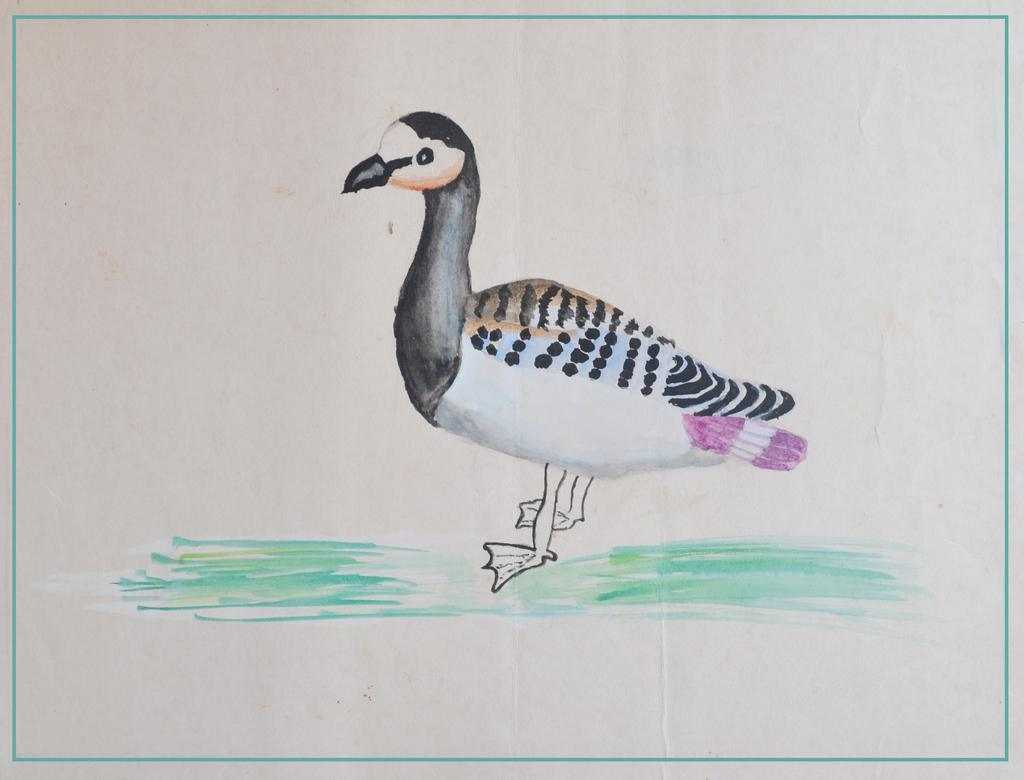What is depicted in the image? There is a drawing of a duck in the image. What is the medium of the drawing? The drawing is on a piece of paper. What type of finger can be seen wearing a skirt in the image? There are no fingers or skirts present in the image; it features a drawing of a duck on a piece of paper. 